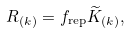Convert formula to latex. <formula><loc_0><loc_0><loc_500><loc_500>R _ { ( k ) } = f _ { \text {rep} } \widetilde { K } _ { ( k ) } ,</formula> 